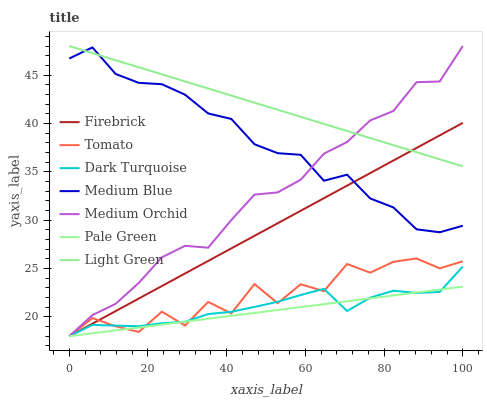Does Pale Green have the minimum area under the curve?
Answer yes or no. Yes. Does Light Green have the maximum area under the curve?
Answer yes or no. Yes. Does Dark Turquoise have the minimum area under the curve?
Answer yes or no. No. Does Dark Turquoise have the maximum area under the curve?
Answer yes or no. No. Is Pale Green the smoothest?
Answer yes or no. Yes. Is Tomato the roughest?
Answer yes or no. Yes. Is Dark Turquoise the smoothest?
Answer yes or no. No. Is Dark Turquoise the roughest?
Answer yes or no. No. Does Tomato have the lowest value?
Answer yes or no. Yes. Does Medium Blue have the lowest value?
Answer yes or no. No. Does Light Green have the highest value?
Answer yes or no. Yes. Does Dark Turquoise have the highest value?
Answer yes or no. No. Is Dark Turquoise less than Medium Blue?
Answer yes or no. Yes. Is Medium Blue greater than Pale Green?
Answer yes or no. Yes. Does Firebrick intersect Dark Turquoise?
Answer yes or no. Yes. Is Firebrick less than Dark Turquoise?
Answer yes or no. No. Is Firebrick greater than Dark Turquoise?
Answer yes or no. No. Does Dark Turquoise intersect Medium Blue?
Answer yes or no. No. 